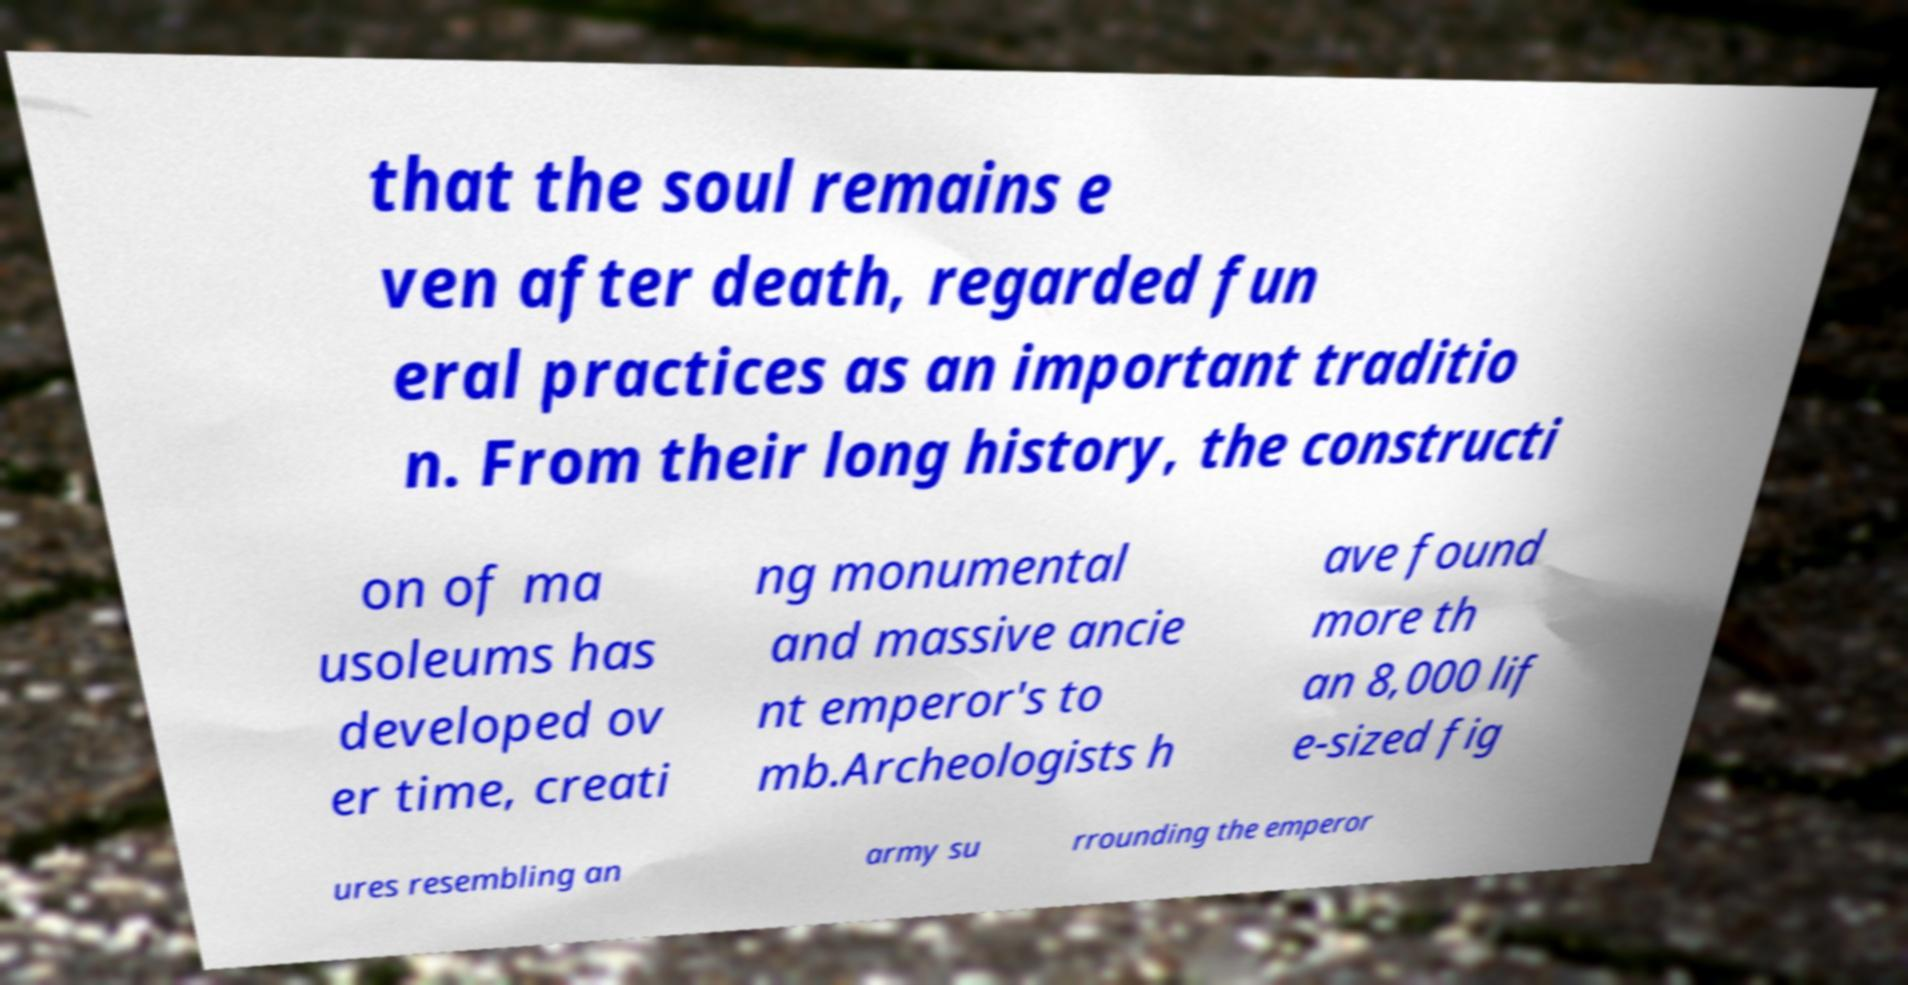Could you extract and type out the text from this image? that the soul remains e ven after death, regarded fun eral practices as an important traditio n. From their long history, the constructi on of ma usoleums has developed ov er time, creati ng monumental and massive ancie nt emperor's to mb.Archeologists h ave found more th an 8,000 lif e-sized fig ures resembling an army su rrounding the emperor 